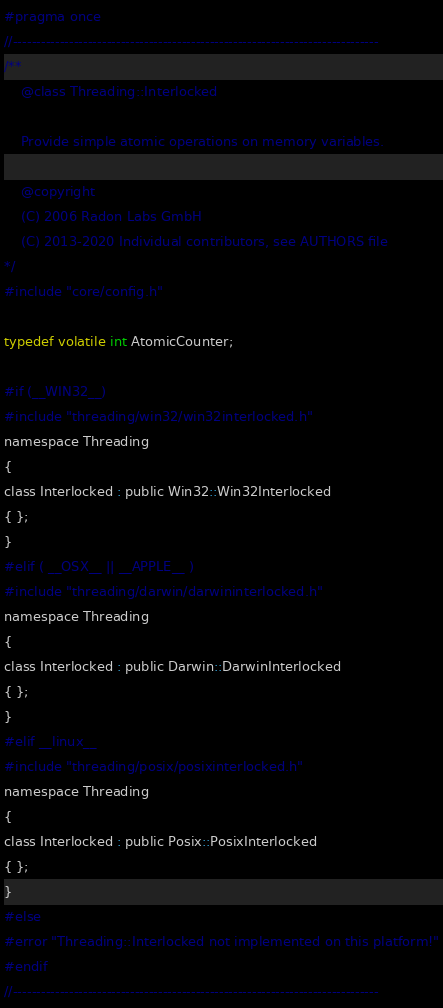<code> <loc_0><loc_0><loc_500><loc_500><_C_>#pragma once
//------------------------------------------------------------------------------
/**
    @class Threading::Interlocked
    
    Provide simple atomic operations on memory variables.
    
    @copyright
    (C) 2006 Radon Labs GmbH
    (C) 2013-2020 Individual contributors, see AUTHORS file
*/
#include "core/config.h"

typedef volatile int AtomicCounter;

#if (__WIN32__)
#include "threading/win32/win32interlocked.h"
namespace Threading
{
class Interlocked : public Win32::Win32Interlocked
{ };
}
#elif ( __OSX__ || __APPLE__ )
#include "threading/darwin/darwininterlocked.h"
namespace Threading
{
class Interlocked : public Darwin::DarwinInterlocked
{ };
}
#elif __linux__
#include "threading/posix/posixinterlocked.h"
namespace Threading
{
class Interlocked : public Posix::PosixInterlocked
{ };
}
#else
#error "Threading::Interlocked not implemented on this platform!"
#endif
//------------------------------------------------------------------------------
</code> 